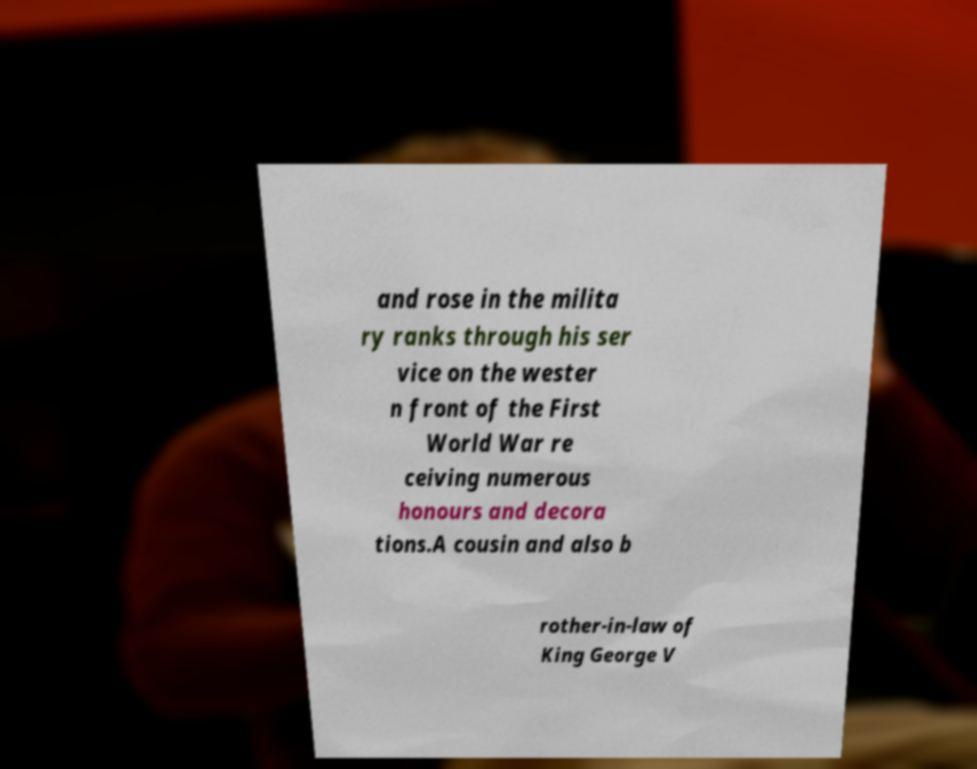Please read and relay the text visible in this image. What does it say? and rose in the milita ry ranks through his ser vice on the wester n front of the First World War re ceiving numerous honours and decora tions.A cousin and also b rother-in-law of King George V 